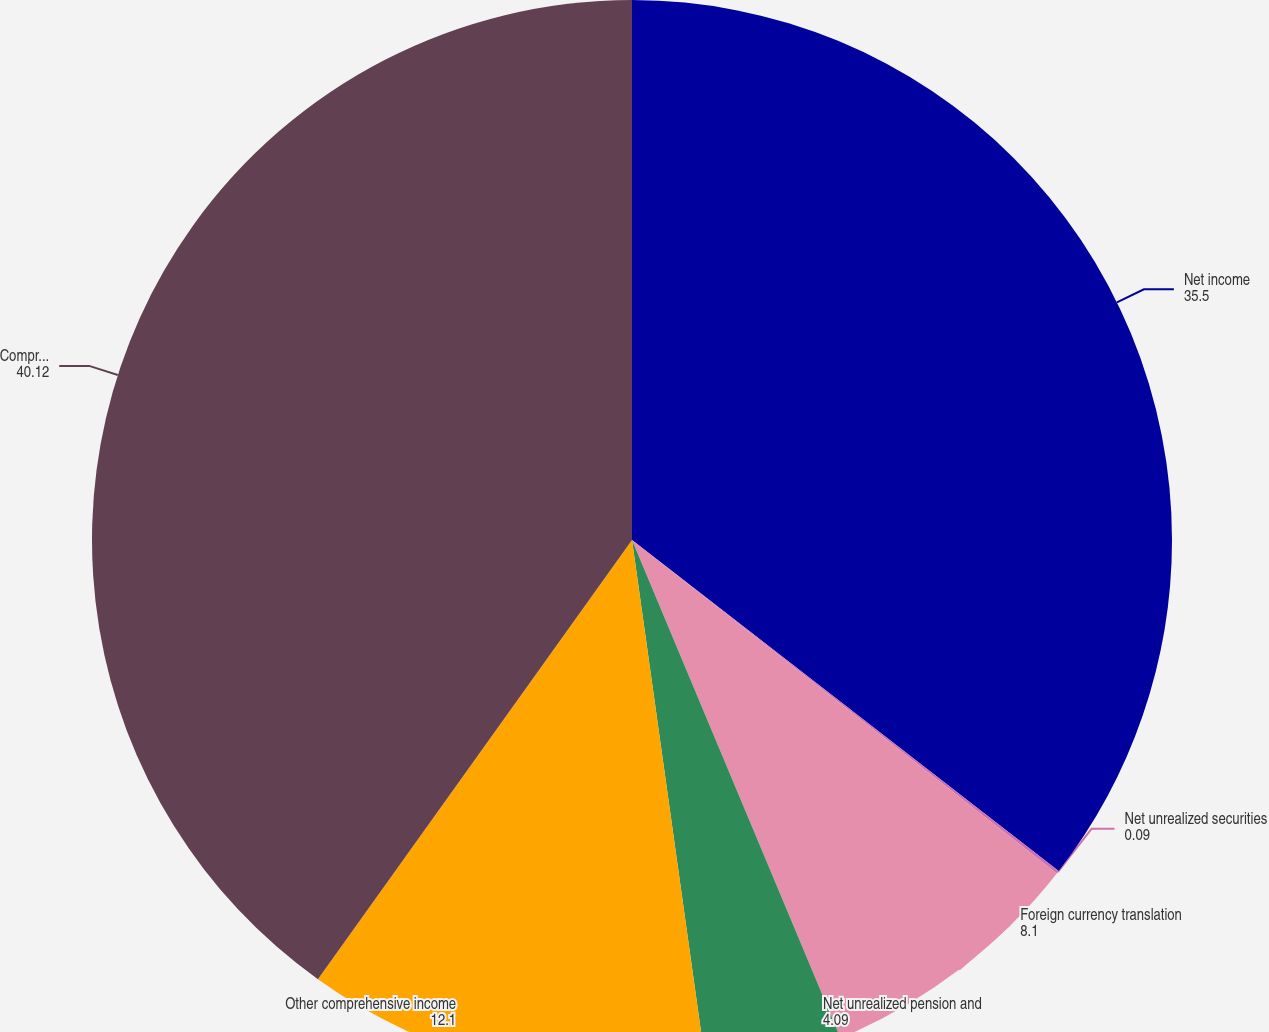<chart> <loc_0><loc_0><loc_500><loc_500><pie_chart><fcel>Net income<fcel>Net unrealized securities<fcel>Foreign currency translation<fcel>Net unrealized pension and<fcel>Other comprehensive income<fcel>Comprehensive income<nl><fcel>35.5%<fcel>0.09%<fcel>8.1%<fcel>4.09%<fcel>12.1%<fcel>40.12%<nl></chart> 